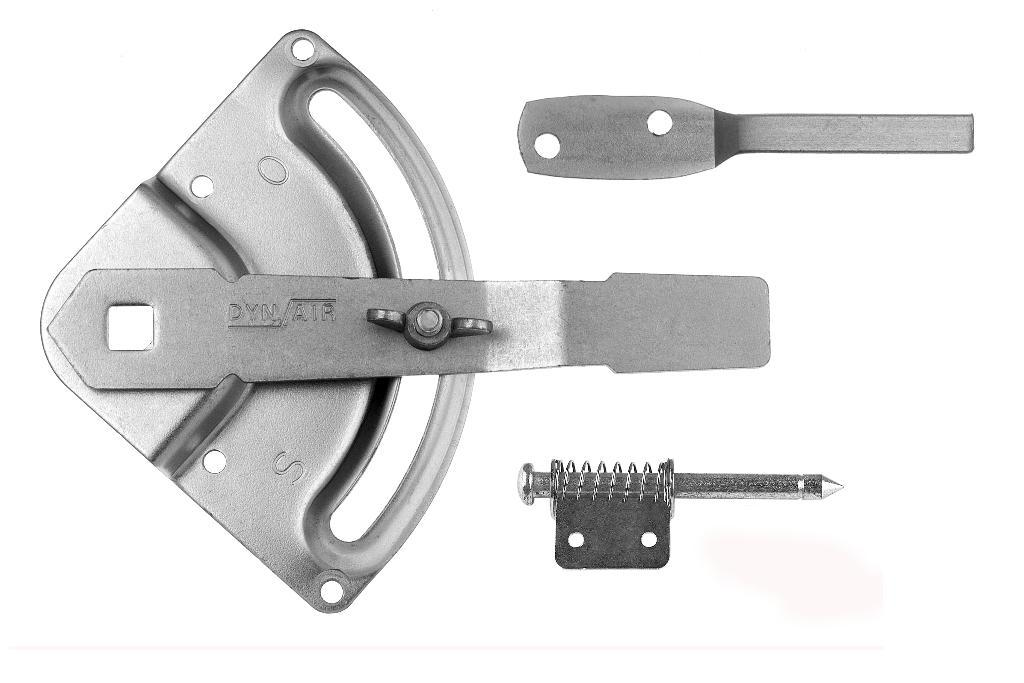What type of machine is the image a part of? The image is a part of an air compressor. What type of parenting advice can be seen in the image? There is no parenting advice present in the image, as it is a part of an air compressor. What type of bread is being toasted in the image? There is no bread or toasting activity present in the image, as it is a part of an air compressor. 